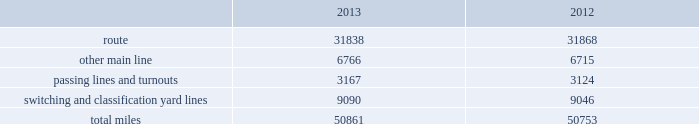Item 2 .
Properties we employ a variety of assets in the management and operation of our rail business .
Our rail network covers 23 states in the western two-thirds of the u.s .
Our rail network includes 31838 route miles .
We own 26009 miles and operate on the remainder pursuant to trackage rights or leases .
The table describes track miles at december 31 , 2013 and 2012 .
2013 2012 .
Headquarters building we maintain our headquarters in omaha , nebraska .
The facility has 1.2 million square feet of space for approximately 4000 employees and is subject to a financing arrangement .
Harriman dispatching center the harriman dispatching center ( hdc ) , located in omaha , nebraska , is our primary dispatching facility .
It is linked to regional dispatching and locomotive management facilities at various locations along our .
At december 312013 what was the percent of the route miles to the total track miles? 
Computations: (31838 / 50861)
Answer: 0.62598. Item 2 .
Properties we employ a variety of assets in the management and operation of our rail business .
Our rail network covers 23 states in the western two-thirds of the u.s .
Our rail network includes 31838 route miles .
We own 26009 miles and operate on the remainder pursuant to trackage rights or leases .
The table describes track miles at december 31 , 2013 and 2012 .
2013 2012 .
Headquarters building we maintain our headquarters in omaha , nebraska .
The facility has 1.2 million square feet of space for approximately 4000 employees and is subject to a financing arrangement .
Harriman dispatching center the harriman dispatching center ( hdc ) , located in omaha , nebraska , is our primary dispatching facility .
It is linked to regional dispatching and locomotive management facilities at various locations along our .
What is the percent of the owned and operated of the rail network route miles? 
Computations: (26009 / 31838)
Answer: 0.81692. 